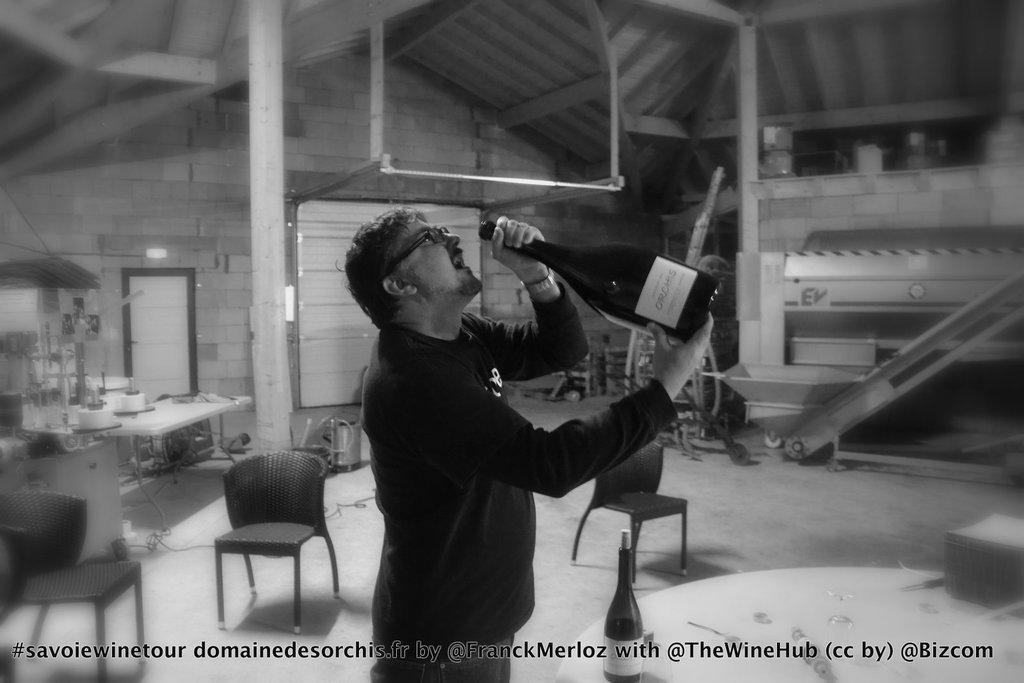What can be seen in the image? There is a person in the image. What is the person wearing? The person is wearing a black shirt. What is the person doing in the image? The person is standing. What is the person holding in the image? The person is holding a glass bottle. What can be seen in the background of the image? There are chairs and other objects in the background of the image. How many pizzas are on the guitar in the image? There are no pizzas or guitars present in the image. What type of quartz can be seen in the image? There is no quartz present in the image. 